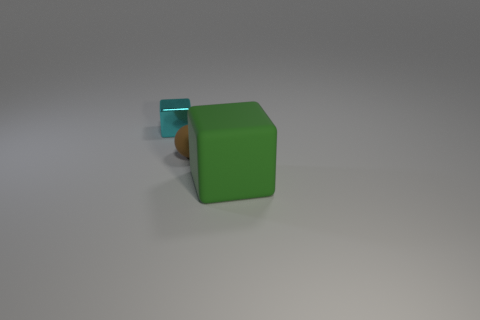Is there anything else that has the same material as the tiny cyan thing?
Your response must be concise. No. What number of objects are things that are behind the matte sphere or cyan cubes?
Your answer should be very brief. 1. What number of things are cubes or blocks in front of the tiny metallic object?
Offer a very short reply. 2. How many big green blocks are behind the block to the left of the block that is in front of the cyan object?
Keep it short and to the point. 0. What material is the other thing that is the same size as the brown rubber object?
Provide a succinct answer. Metal. Is there a cyan cube that has the same size as the brown ball?
Provide a succinct answer. Yes. The metal cube has what color?
Keep it short and to the point. Cyan. There is a block that is in front of the block that is behind the big green matte block; what color is it?
Provide a succinct answer. Green. There is a object that is behind the matte object behind the block that is in front of the small metal object; what is its shape?
Keep it short and to the point. Cube. What number of objects are the same material as the ball?
Ensure brevity in your answer.  1. 